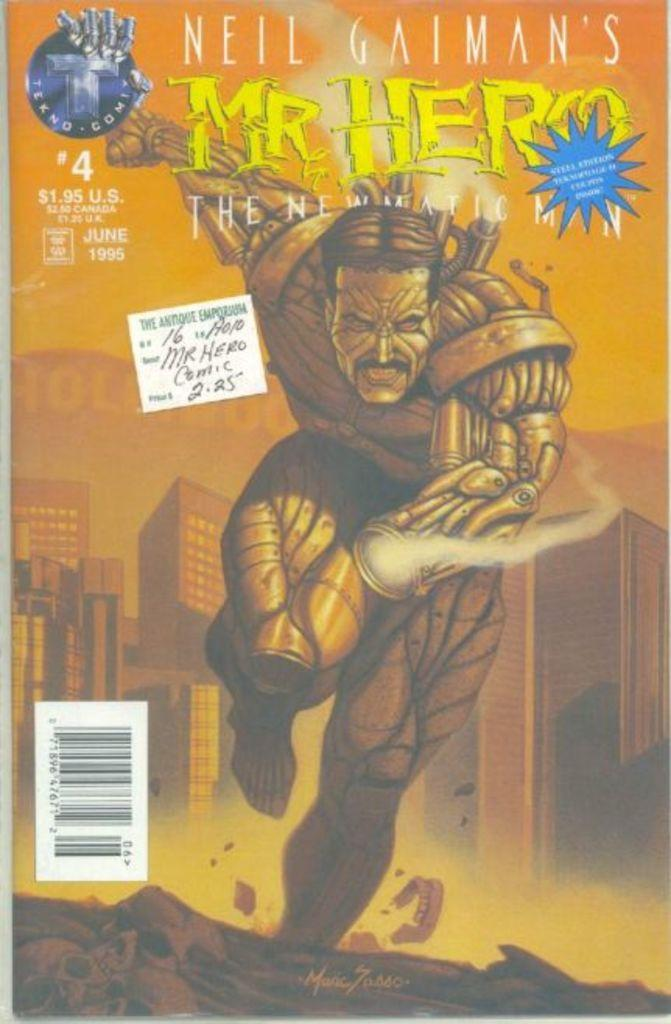<image>
Summarize the visual content of the image. A copy of a comic book by Neil Gaiman called Mr. Hero. 